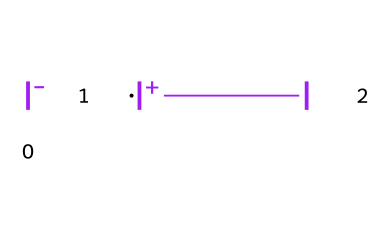What is the total number of iodine atoms in the structure? The SMILES representation shows three iodine entities (two iodine anions [I-] and one iodine cation [I+]) indicated separately, giving a total of three iodine atoms.
Answer: three How many covalent bonds are present in the structure? The structure consists of two types of iodine: one positively charged and two negatively charged. In its molecular form, these are typically connected through covalent bonds. Given the absence of any explicit multiple bonds or further connections, there can be inferred single bonds in a rough equilibrium of interaction in ionics, leading to a minimal portrayal of a three-centered interaction without a precise count in representation; however, this molecular form indicates interactivity among three.
Answer: two What type of halogen is represented in this chemical structure? The chemical structure represents iodine, which is a halogen and is identified in the periodic table as element 53, a member of the halogen group.
Answer: iodine What is the oxidation state of the central iodine atom? In the provided structure, the central iodine shows a positive charge, indicating it has an oxidation state of +1. This means it has lost electrons, characteristic of its form in the oxidation context related to the anion's balance.
Answer: +1 Why is iodine important in sports disinfectants? Iodine is prominent in disinfectants due to its antibacterial and antiviral properties, allowing it to effectively eliminate pathogens and infections on skin surfaces, thus supporting health and hygiene in sports environments.
Answer: antibacterial 